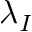<formula> <loc_0><loc_0><loc_500><loc_500>\lambda _ { I }</formula> 